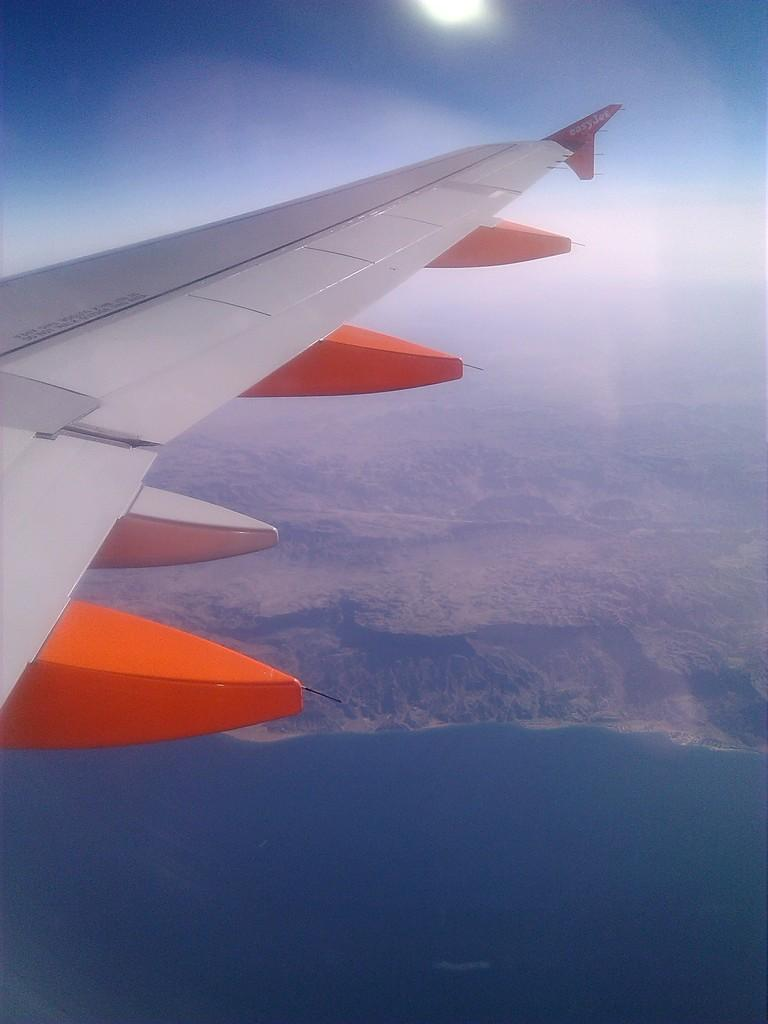What is the main subject of the image? The main subject of the image is an airplane. From where was the image captured? The image is captured from the airplane. What type of landscape can be seen on the ground? There are beautiful mountains and a sea visible on the ground. How many legs can be seen supporting the pencil in the image? There is no pencil present in the image, so it is not possible to determine the number of legs supporting it. 